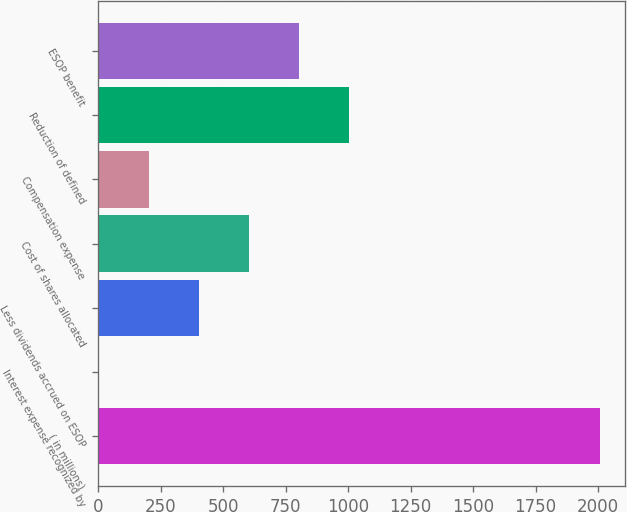<chart> <loc_0><loc_0><loc_500><loc_500><bar_chart><fcel>( in millions)<fcel>Interest expense recognized by<fcel>Less dividends accrued on ESOP<fcel>Cost of shares allocated<fcel>Compensation expense<fcel>Reduction of defined<fcel>ESOP benefit<nl><fcel>2006<fcel>4<fcel>404.4<fcel>604.6<fcel>204.2<fcel>1005<fcel>804.8<nl></chart> 